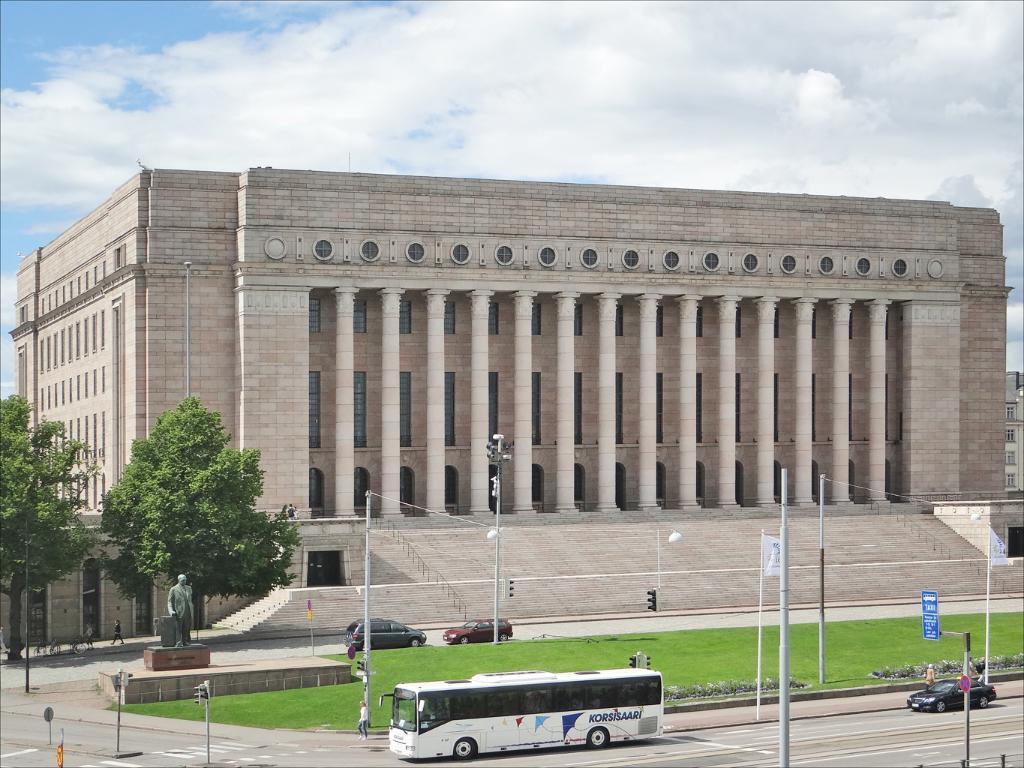Describe this image in one or two sentences. In this image there is a building we can see trees. On the left there is a statue. At the bottom there are vehicles on the road and we can see people. There are poles. In the background there is sky. 